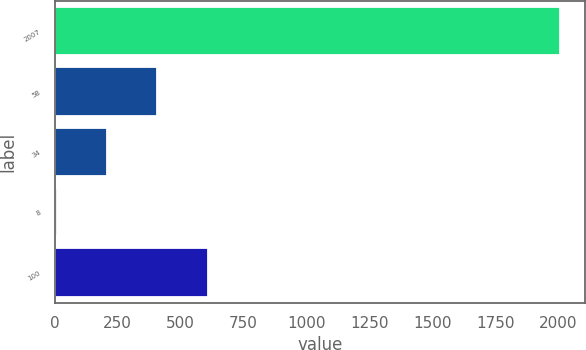Convert chart to OTSL. <chart><loc_0><loc_0><loc_500><loc_500><bar_chart><fcel>2007<fcel>58<fcel>34<fcel>8<fcel>100<nl><fcel>2006<fcel>407.6<fcel>207.8<fcel>8<fcel>607.4<nl></chart> 